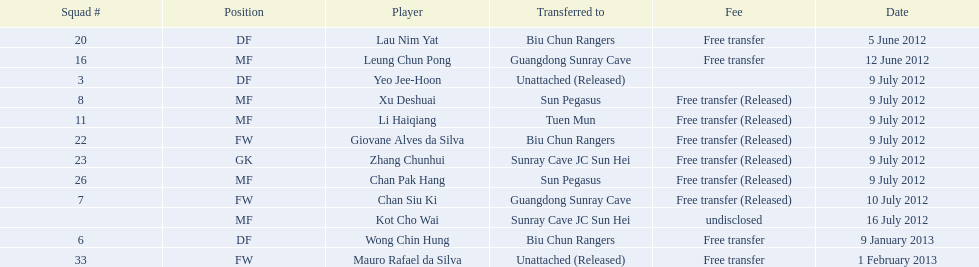Which players are listed? Lau Nim Yat, Leung Chun Pong, Yeo Jee-Hoon, Xu Deshuai, Li Haiqiang, Giovane Alves da Silva, Zhang Chunhui, Chan Pak Hang, Chan Siu Ki, Kot Cho Wai, Wong Chin Hung, Mauro Rafael da Silva. Which dates were players transferred to the biu chun rangers? 5 June 2012, 9 July 2012, 9 January 2013. Of those which is the date for wong chin hung? 9 January 2013. Which athletes participated in the 2012-13 south china aa season? Lau Nim Yat, Leung Chun Pong, Yeo Jee-Hoon, Xu Deshuai, Li Haiqiang, Giovane Alves da Silva, Zhang Chunhui, Chan Pak Hang, Chan Siu Ki, Kot Cho Wai, Wong Chin Hung, Mauro Rafael da Silva. Among them, who were free transfers that weren't let go? Lau Nim Yat, Leung Chun Pong, Wong Chin Hung, Mauro Rafael da Silva. From these, who belonged to squad # 6? Wong Chin Hung. When was their transfer date? 9 January 2013. 